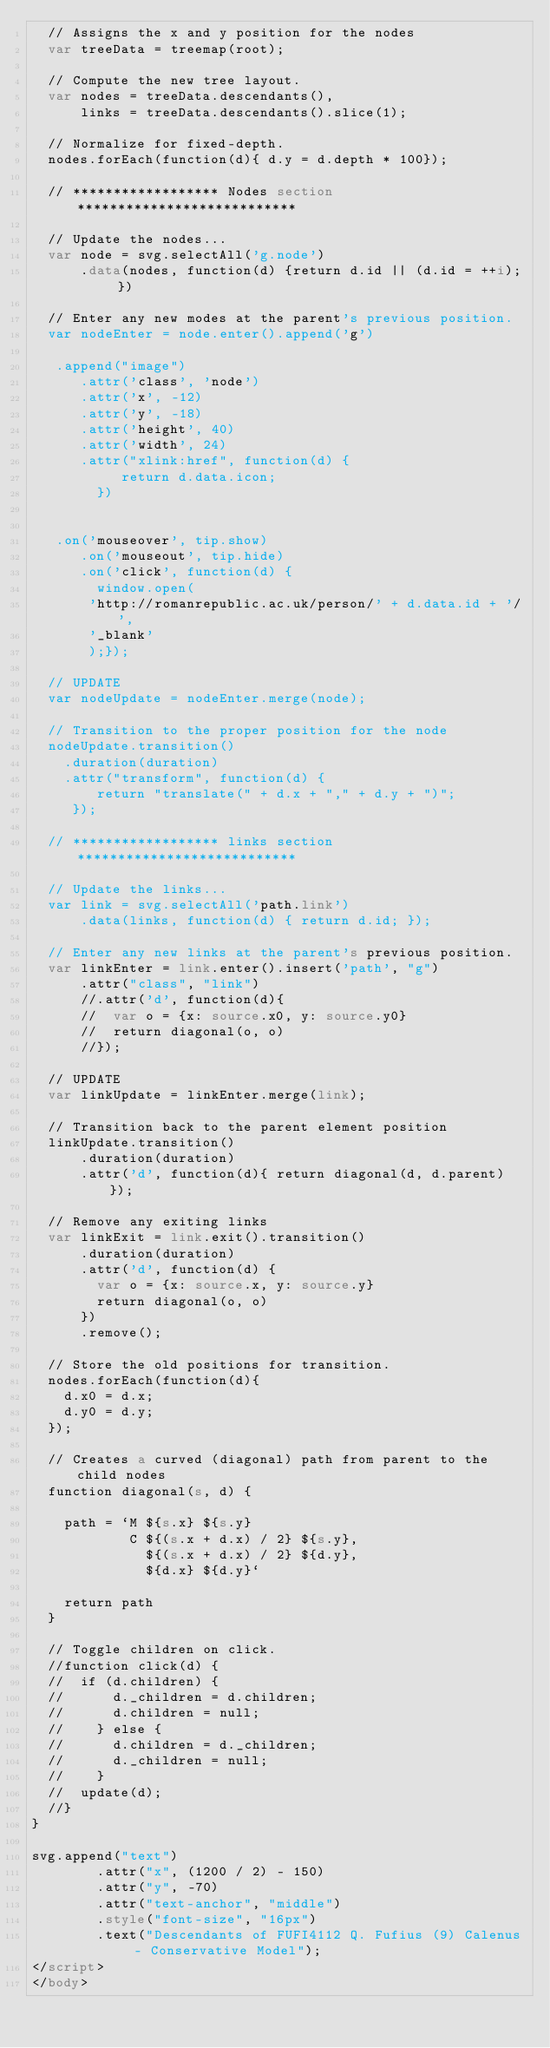<code> <loc_0><loc_0><loc_500><loc_500><_HTML_>  // Assigns the x and y position for the nodes
  var treeData = treemap(root);

  // Compute the new tree layout.
  var nodes = treeData.descendants(),
      links = treeData.descendants().slice(1);

  // Normalize for fixed-depth.
  nodes.forEach(function(d){ d.y = d.depth * 100});

  // ****************** Nodes section ***************************

  // Update the nodes...
  var node = svg.selectAll('g.node')
      .data(nodes, function(d) {return d.id || (d.id = ++i); })

  // Enter any new modes at the parent's previous position.
  var nodeEnter = node.enter().append('g')
      
   .append("image")
      .attr('class', 'node') 
      .attr('x', -12)
      .attr('y', -18)
      .attr('height', 40)
      .attr('width', 24)
      .attr("xlink:href", function(d) {
           return d.data.icon;
        })
 
   
   .on('mouseover', tip.show)
      .on('mouseout', tip.hide)
      .on('click', function(d) {
        window.open(
       'http://romanrepublic.ac.uk/person/' + d.data.id + '/',
       '_blank'
       );});

  // UPDATE
  var nodeUpdate = nodeEnter.merge(node);

  // Transition to the proper position for the node
  nodeUpdate.transition()
    .duration(duration)
    .attr("transform", function(d) { 
        return "translate(" + d.x + "," + d.y + ")";
     });

  // ****************** links section ***************************

  // Update the links...
  var link = svg.selectAll('path.link')
      .data(links, function(d) { return d.id; });

  // Enter any new links at the parent's previous position.
  var linkEnter = link.enter().insert('path', "g")
      .attr("class", "link")
      //.attr('d', function(d){
      //  var o = {x: source.x0, y: source.y0}
      //  return diagonal(o, o)
      //});

  // UPDATE
  var linkUpdate = linkEnter.merge(link);

  // Transition back to the parent element position
  linkUpdate.transition()
      .duration(duration)
      .attr('d', function(d){ return diagonal(d, d.parent) });

  // Remove any exiting links
  var linkExit = link.exit().transition()
      .duration(duration)
      .attr('d', function(d) {
        var o = {x: source.x, y: source.y}
        return diagonal(o, o)
      })
      .remove();

  // Store the old positions for transition.
  nodes.forEach(function(d){
    d.x0 = d.x;
    d.y0 = d.y;
  });

  // Creates a curved (diagonal) path from parent to the child nodes
  function diagonal(s, d) {

    path = `M ${s.x} ${s.y}
            C ${(s.x + d.x) / 2} ${s.y},
              ${(s.x + d.x) / 2} ${d.y},
              ${d.x} ${d.y}`

    return path
  }

  // Toggle children on click.
  //function click(d) {
  //  if (d.children) {
  //      d._children = d.children;
  //      d.children = null;
  //    } else {
  //      d.children = d._children;
  //      d._children = null;
  //    }
  //  update(d);
  //}
}

svg.append("text")
        .attr("x", (1200 / 2) - 150)             
        .attr("y", -70)
        .attr("text-anchor", "middle")  
        .style("font-size", "16px") 
        .text("Descendants of FUFI4112 Q. Fufius (9) Calenus - Conservative Model");
</script>
</body></code> 